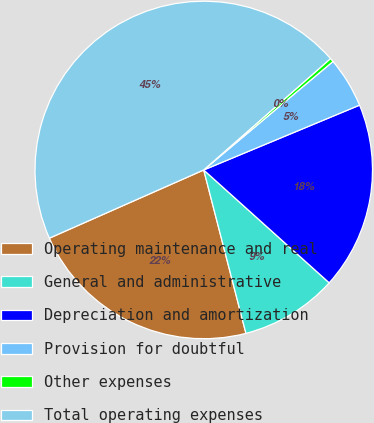<chart> <loc_0><loc_0><loc_500><loc_500><pie_chart><fcel>Operating maintenance and real<fcel>General and administrative<fcel>Depreciation and amortization<fcel>Provision for doubtful<fcel>Other expenses<fcel>Total operating expenses<nl><fcel>22.4%<fcel>9.32%<fcel>17.93%<fcel>4.84%<fcel>0.36%<fcel>45.15%<nl></chart> 